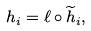<formula> <loc_0><loc_0><loc_500><loc_500>h _ { i } = \ell \circ \widetilde { h } _ { i } ,</formula> 